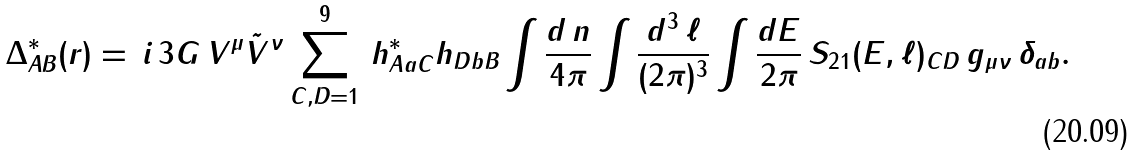Convert formula to latex. <formula><loc_0><loc_0><loc_500><loc_500>\Delta ^ { * } _ { A B } ( { r } ) = \, i \, 3 G \, V ^ { \mu } \tilde { V } ^ { \nu } \sum _ { C , D = 1 } ^ { 9 } \, h ^ { * } _ { A a C } h _ { D b B } \int \frac { d \, { n } } { 4 \pi } \int \frac { d ^ { 3 } \, \ell } { ( 2 \pi ) ^ { 3 } } \int \frac { d E } { 2 \pi } \, S _ { 2 1 } ( E , \ell ) _ { C D } \, g _ { \mu \nu } \, \delta _ { a b } .</formula> 